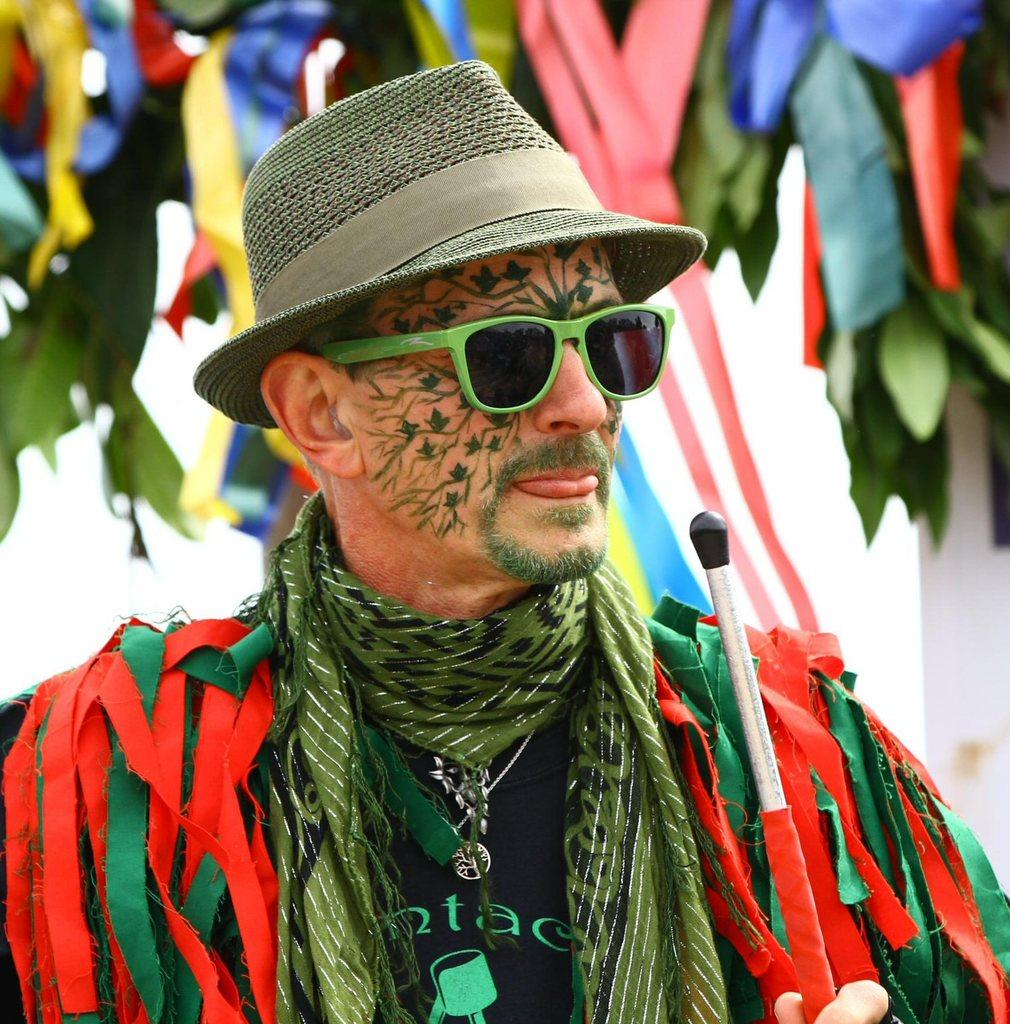Who is the main subject in the image? There is a man in the center of the image. What accessories is the man wearing? The man is wearing a hat and glasses. What is the man holding in the image? The man is holding an object. What can be seen in the background of the image? There are leaves and colorful flags in the background of the image. What type of ant can be seen crawling on the man's hat in the image? There are no ants present in the image, and therefore no such activity can be observed. 